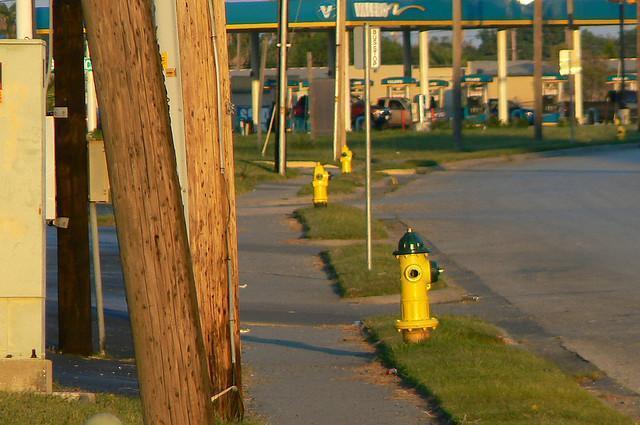How many dogs are sitting down?
Give a very brief answer. 0. 